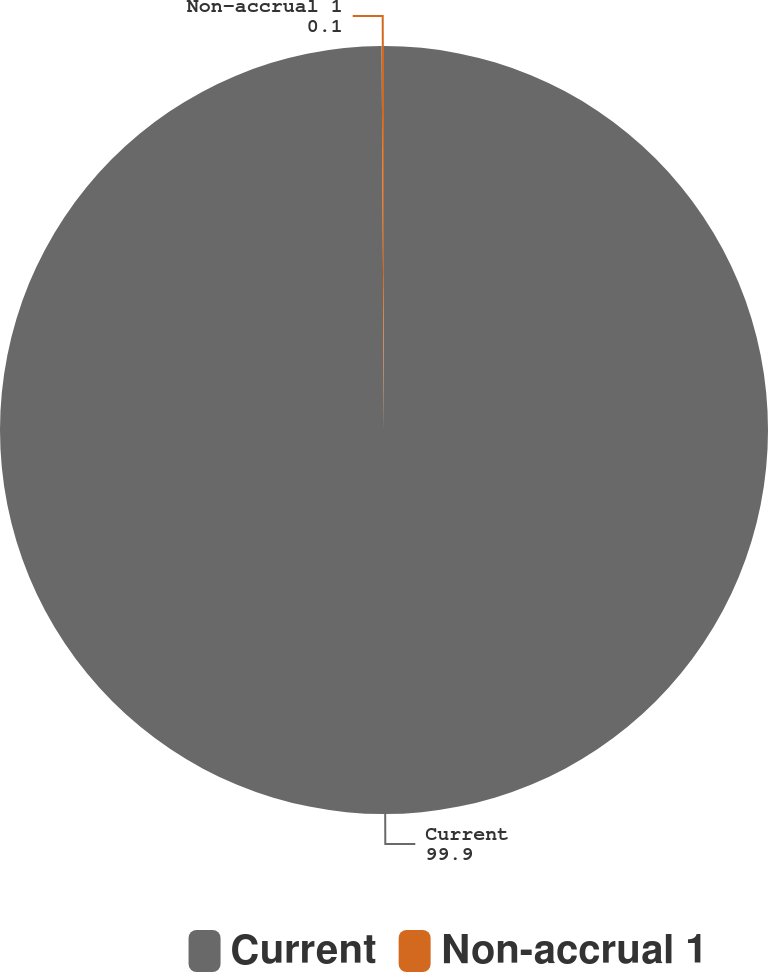Convert chart to OTSL. <chart><loc_0><loc_0><loc_500><loc_500><pie_chart><fcel>Current<fcel>Non-accrual 1<nl><fcel>99.9%<fcel>0.1%<nl></chart> 